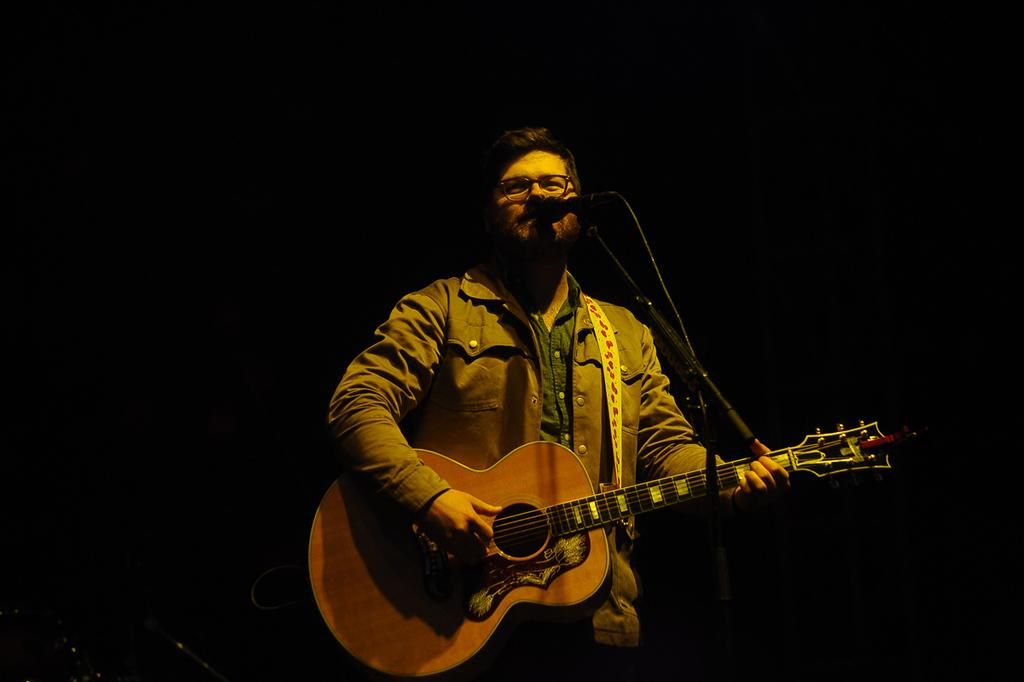Who is the main subject in the image? There is a guy in the image. Where is the guy positioned in the image? The guy is standing in the center of the image. What is the guy holding in the image? The guy is holding a guitar. What might the guy be doing with the guitar? The guy is likely playing the guitar. What object is in front of the guy? There is a microphone in front of the guy. How many beds can be seen in the image? There are no beds present in the image. What type of pet is sitting next to the guy in the image? There is no pet visible in the image. 